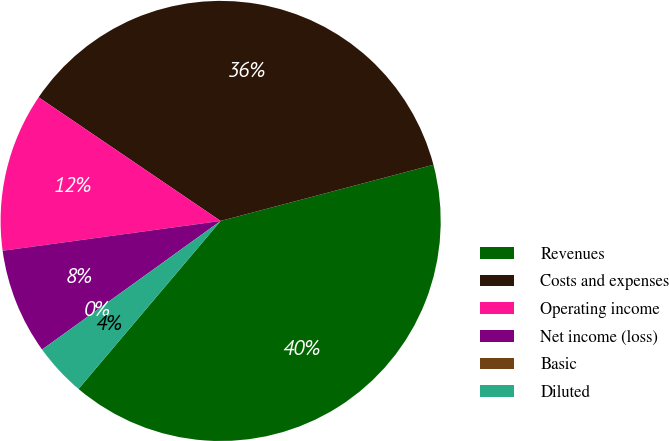<chart> <loc_0><loc_0><loc_500><loc_500><pie_chart><fcel>Revenues<fcel>Costs and expenses<fcel>Operating income<fcel>Net income (loss)<fcel>Basic<fcel>Diluted<nl><fcel>40.28%<fcel>36.39%<fcel>11.66%<fcel>7.77%<fcel>0.0%<fcel>3.89%<nl></chart> 